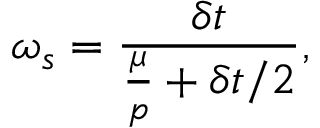Convert formula to latex. <formula><loc_0><loc_0><loc_500><loc_500>\omega _ { s } = \frac { \delta t } { \frac { \mu } { p } + \delta t / 2 } ,</formula> 